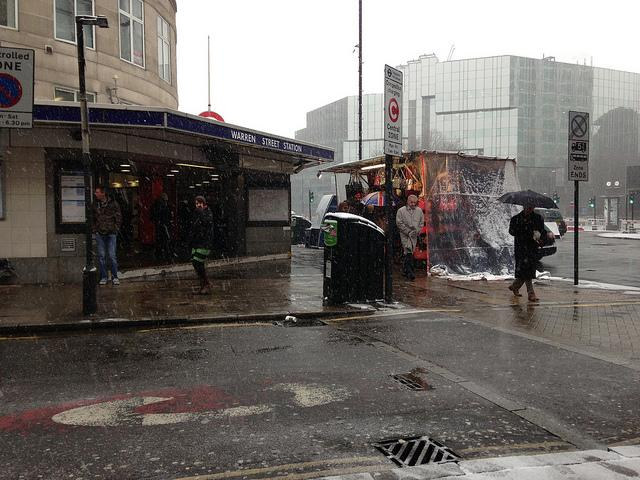What does the item the person on the far right is holding protect against? Please explain your reasoning. rain. The plastic sheet cover keeps out rain. 